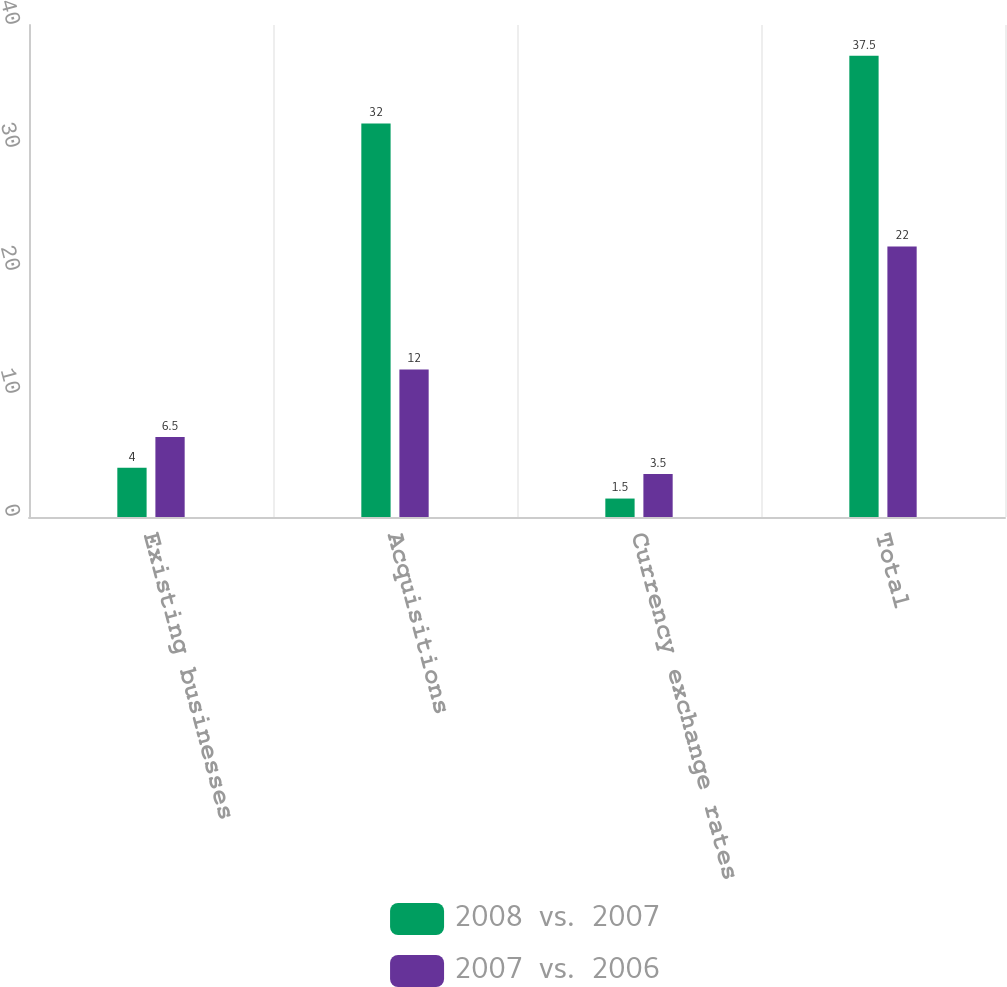<chart> <loc_0><loc_0><loc_500><loc_500><stacked_bar_chart><ecel><fcel>Existing businesses<fcel>Acquisitions<fcel>Currency exchange rates<fcel>Total<nl><fcel>2008  vs.  2007<fcel>4<fcel>32<fcel>1.5<fcel>37.5<nl><fcel>2007  vs.  2006<fcel>6.5<fcel>12<fcel>3.5<fcel>22<nl></chart> 